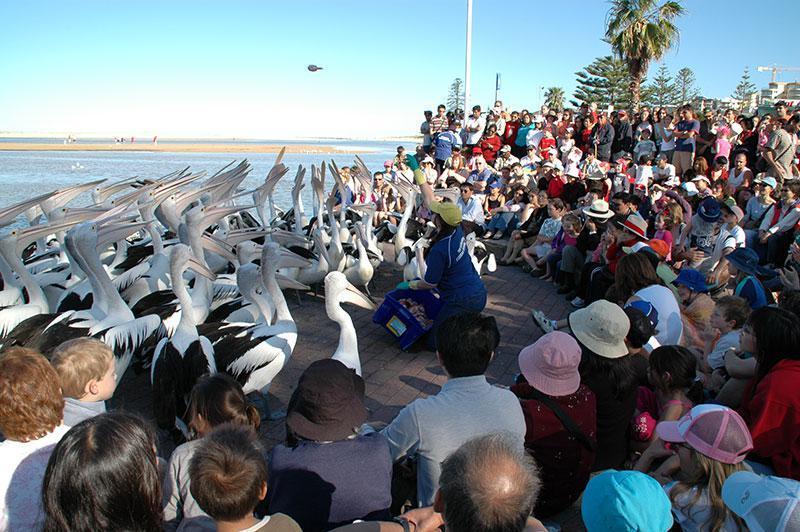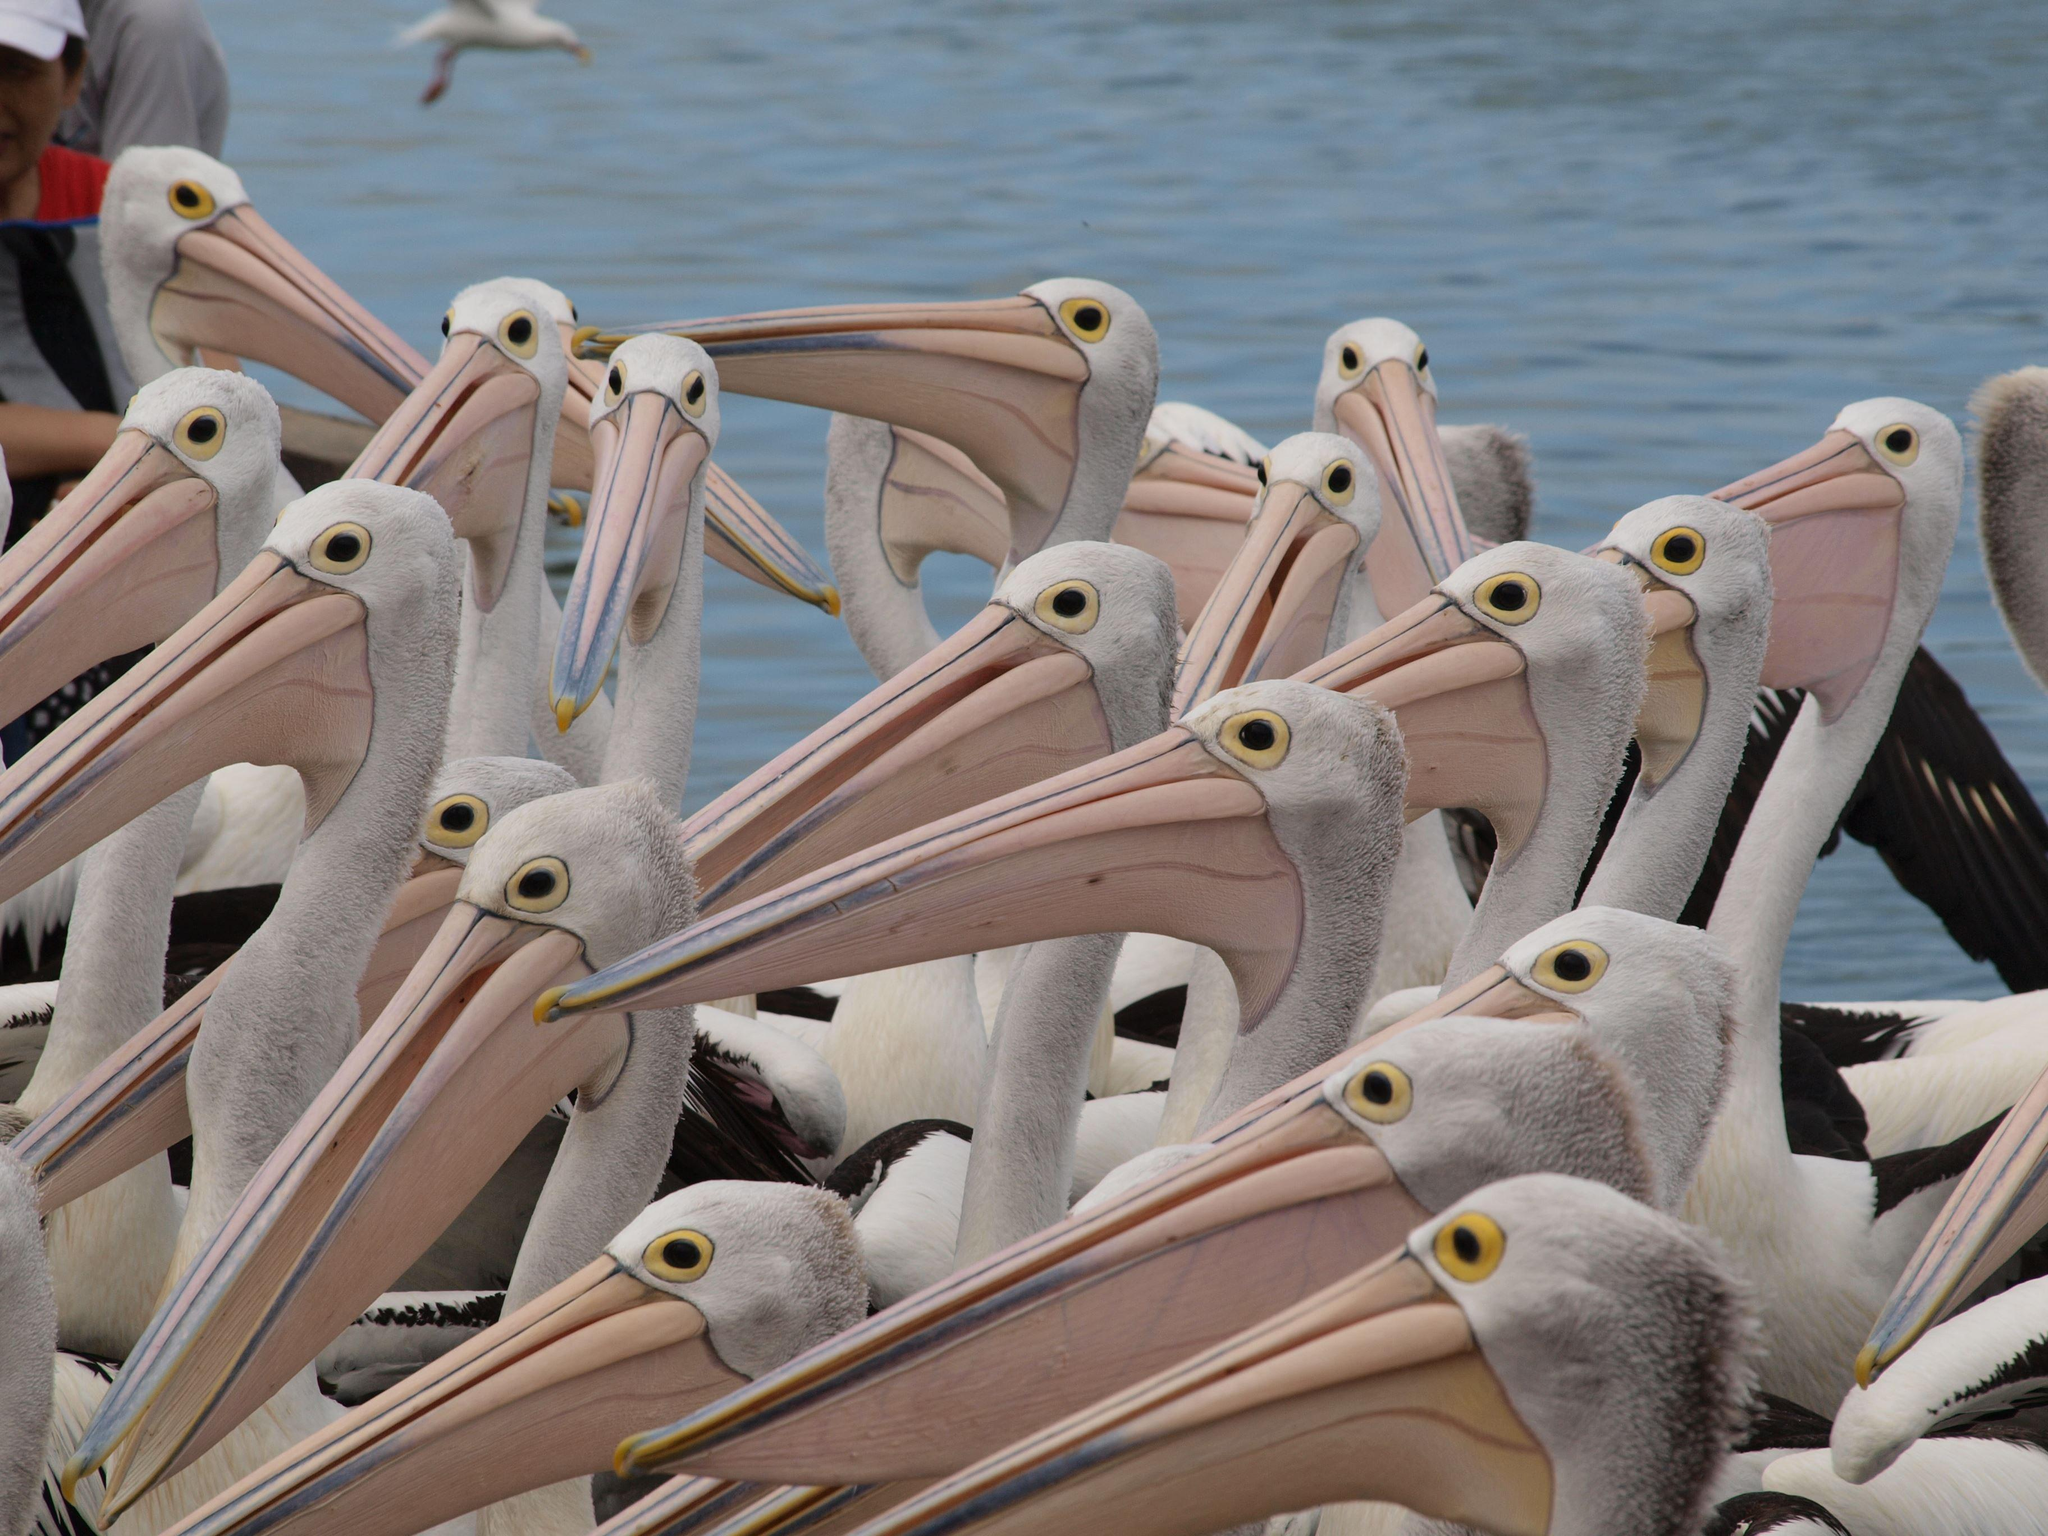The first image is the image on the left, the second image is the image on the right. For the images displayed, is the sentence "There is a red bucket surrounded by many pelicans." factually correct? Answer yes or no. No. 